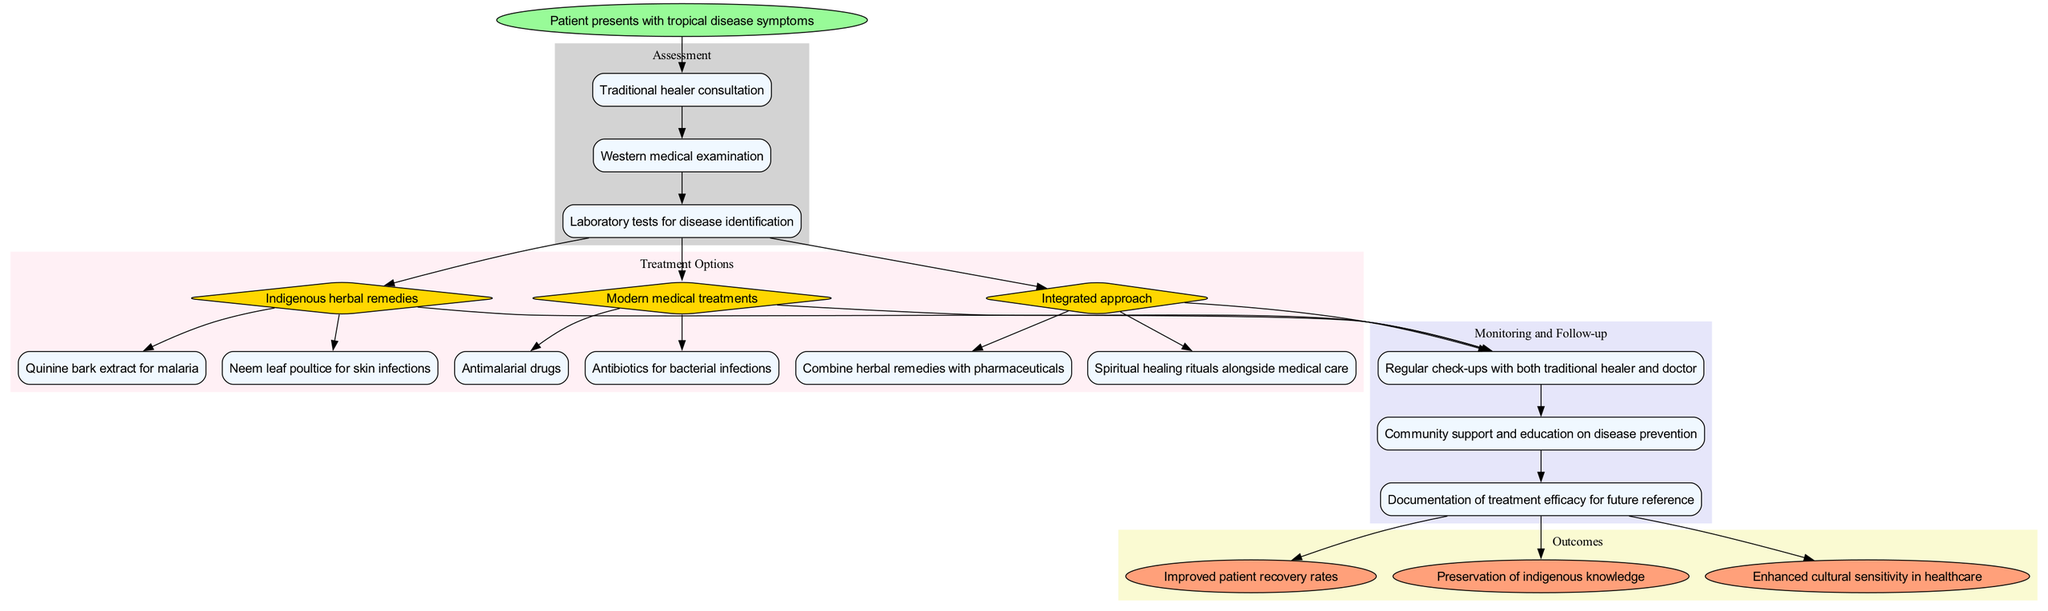What is the starting point of the clinical pathway? The starting point is explicitly labeled in the diagram as "Patient presents with tropical disease symptoms."
Answer: Patient presents with tropical disease symptoms How many assessment steps are included in the diagram? Count the nodes in the "Assessment" section of the diagram, which lists three specific steps: "Traditional healer consultation," "Western medical examination," and "Laboratory tests for disease identification."
Answer: 3 What treatment option uses Quinine bark extract? In the "Treatment Options" section, the treatment option "Indigenous herbal remedies" contains "Quinine bark extract for malaria" as a detail, which specifies its use.
Answer: Indigenous herbal remedies How many monitoring and follow-up steps are outlined in the diagram? Look at the "Monitoring and Follow-up" subgraph; it contains three distinct steps: "Regular check-ups with both traditional healer and doctor," "Community support and education on disease prevention," and "Documentation of treatment efficacy for future reference."
Answer: 3 What is the outcome related to cultural sensitivity? The diagram mentions "Enhanced cultural sensitivity in healthcare" as one of the outcomes in the "Outcomes" section.
Answer: Enhanced cultural sensitivity in healthcare Which treatment option is paired with spiritual healing rituals? The "Integrated approach" treatment option includes combining herbal remedies with pharmaceuticals and mentions spiritual healing rituals as part of the treatment process.
Answer: Integrated approach What connects the last assessment step to the treatment options? The last assessment step, "Laboratory tests for disease identification," connects to the treatment options, indicating that the results from this assessment lead to determining appropriate treatments.
Answer: Laboratory tests for disease identification Which section of the diagram details the connection between treatment and patient monitoring? The "Monitoring and Follow-up" section provides specific steps that are connected to the outcomes of the treatment options, indicating how treatment affects patient follow-up.
Answer: Monitoring and Follow-up What are the two main types of modern medical treatments listed? In the "Modern medical treatments" part of the "Treatment Options" section, the two details listed are "Antimalarial drugs" and "Antibiotics for bacterial infections."
Answer: Antimalarial drugs and Antibiotics for bacterial infections 